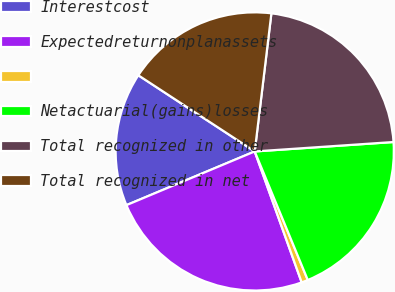<chart> <loc_0><loc_0><loc_500><loc_500><pie_chart><fcel>Interestcost<fcel>Expectedreturnonplanassets<fcel>Unnamed: 2<fcel>Netactuarial(gains)losses<fcel>Total recognized in other<fcel>Total recognized in net<nl><fcel>15.53%<fcel>24.17%<fcel>0.75%<fcel>19.85%<fcel>22.01%<fcel>17.69%<nl></chart> 